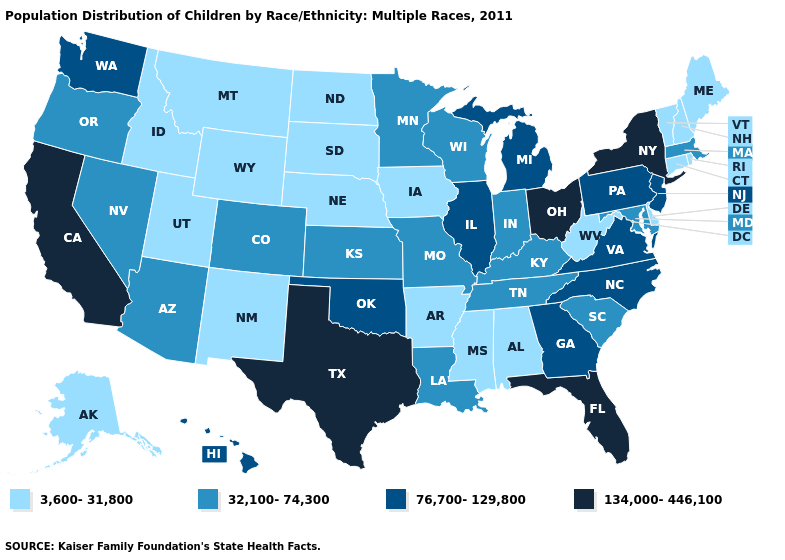What is the highest value in the USA?
Keep it brief. 134,000-446,100. Which states have the lowest value in the Northeast?
Answer briefly. Connecticut, Maine, New Hampshire, Rhode Island, Vermont. Does Florida have the highest value in the USA?
Write a very short answer. Yes. What is the lowest value in the USA?
Be succinct. 3,600-31,800. Name the states that have a value in the range 76,700-129,800?
Quick response, please. Georgia, Hawaii, Illinois, Michigan, New Jersey, North Carolina, Oklahoma, Pennsylvania, Virginia, Washington. Among the states that border Mississippi , which have the lowest value?
Answer briefly. Alabama, Arkansas. Does Oklahoma have a lower value than Colorado?
Short answer required. No. Does the first symbol in the legend represent the smallest category?
Quick response, please. Yes. What is the value of Nebraska?
Give a very brief answer. 3,600-31,800. What is the value of North Carolina?
Concise answer only. 76,700-129,800. Which states hav the highest value in the West?
Short answer required. California. Is the legend a continuous bar?
Write a very short answer. No. Which states have the highest value in the USA?
Write a very short answer. California, Florida, New York, Ohio, Texas. Does Michigan have a higher value than Louisiana?
Quick response, please. Yes. What is the value of West Virginia?
Short answer required. 3,600-31,800. 